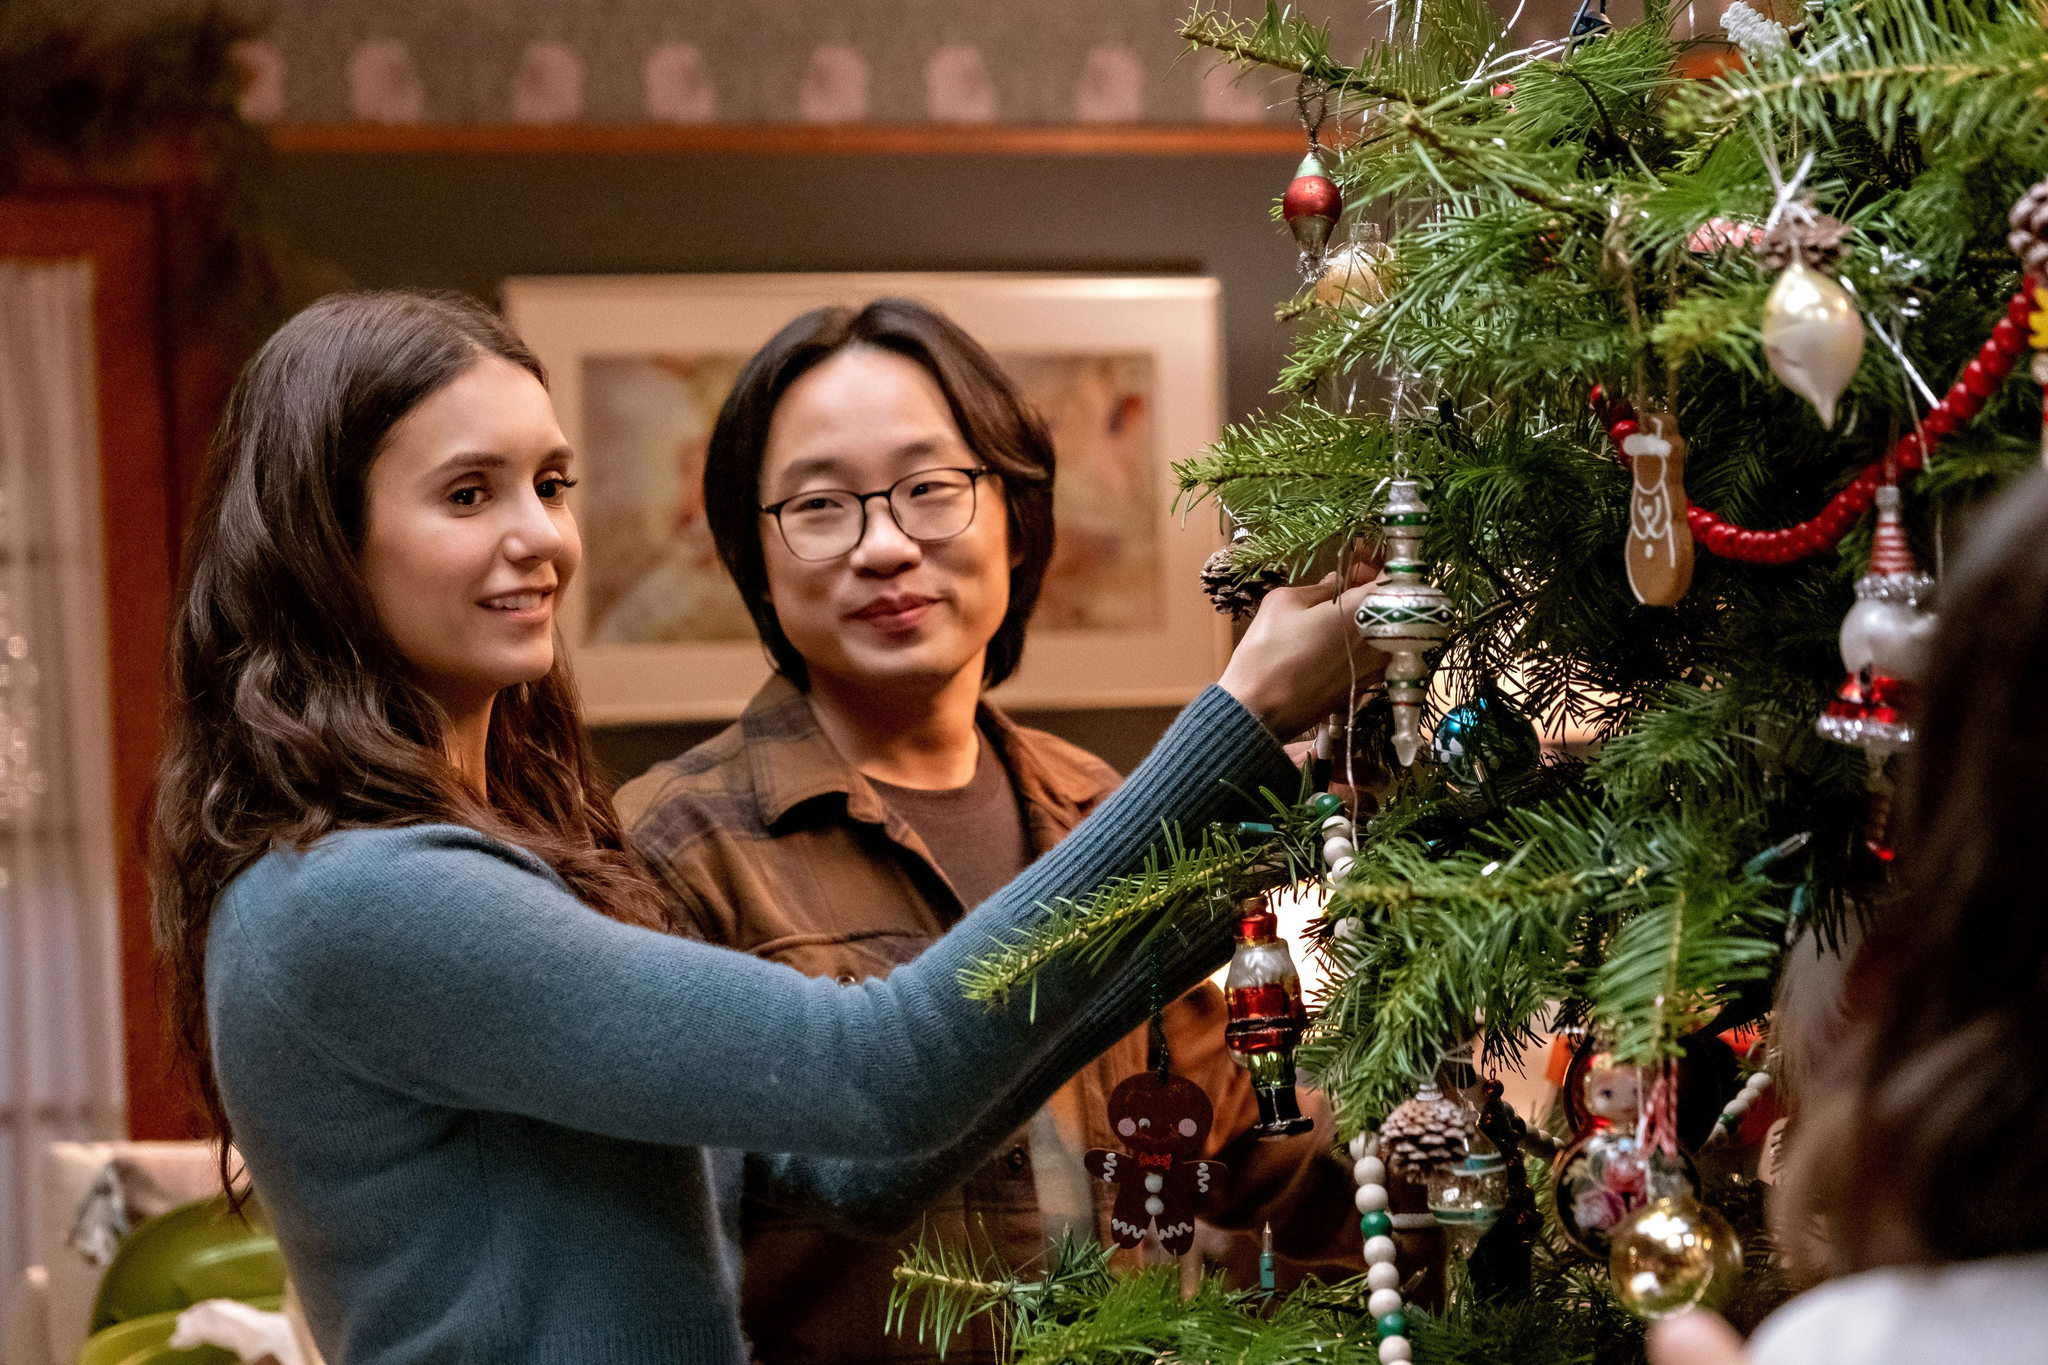What do you think the people in the image are thinking or feeling right now? The people in the image appear to be absorbed in the joyful task of decorating the Christmas tree. The person in the blue sweater is likely feeling a sense of satisfaction and nostalgia, recalling cherished memories associated with each ornament she places on the tree. The individual wearing glasses seems to be savoring the moment, possibly feeling warmth and contentment from the festive tradition and the company of a friend. Together, they exude an atmosphere of shared happiness, bringing light and cheer into the room through their collaborative effort. If they were to share a holiday story, what kind of story would it be? If the people in the image were to share a holiday story, it would likely be a heartwarming tale of family, tradition, and the magic of the holiday season. Perhaps they would recount a beloved childhood memory of baking cookies with family, leaving them out for Santa, and waking up to find them mysteriously nibbled on Christmas morning. They might also share stories of community gatherings, where neighbors come together to decorate, sing carols, and enjoy delicious homemade treats. Their story would undoubtedly emphasize the importance of togetherness, love, and the simple joys of celebrating the holidays with those we hold dear. 